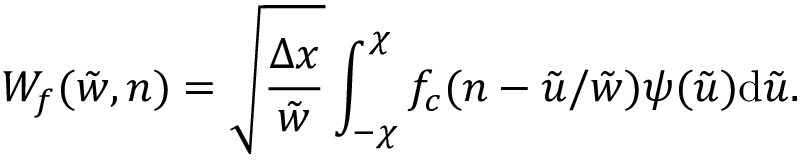<formula> <loc_0><loc_0><loc_500><loc_500>W _ { f } ( \tilde { w } , n ) = \sqrt { \frac { \Delta x } { \tilde { w } } } \int _ { - \chi } ^ { \chi } f _ { c } ( n - \tilde { u } / \tilde { w } ) \psi ( \tilde { u } ) d \tilde { u } .</formula> 